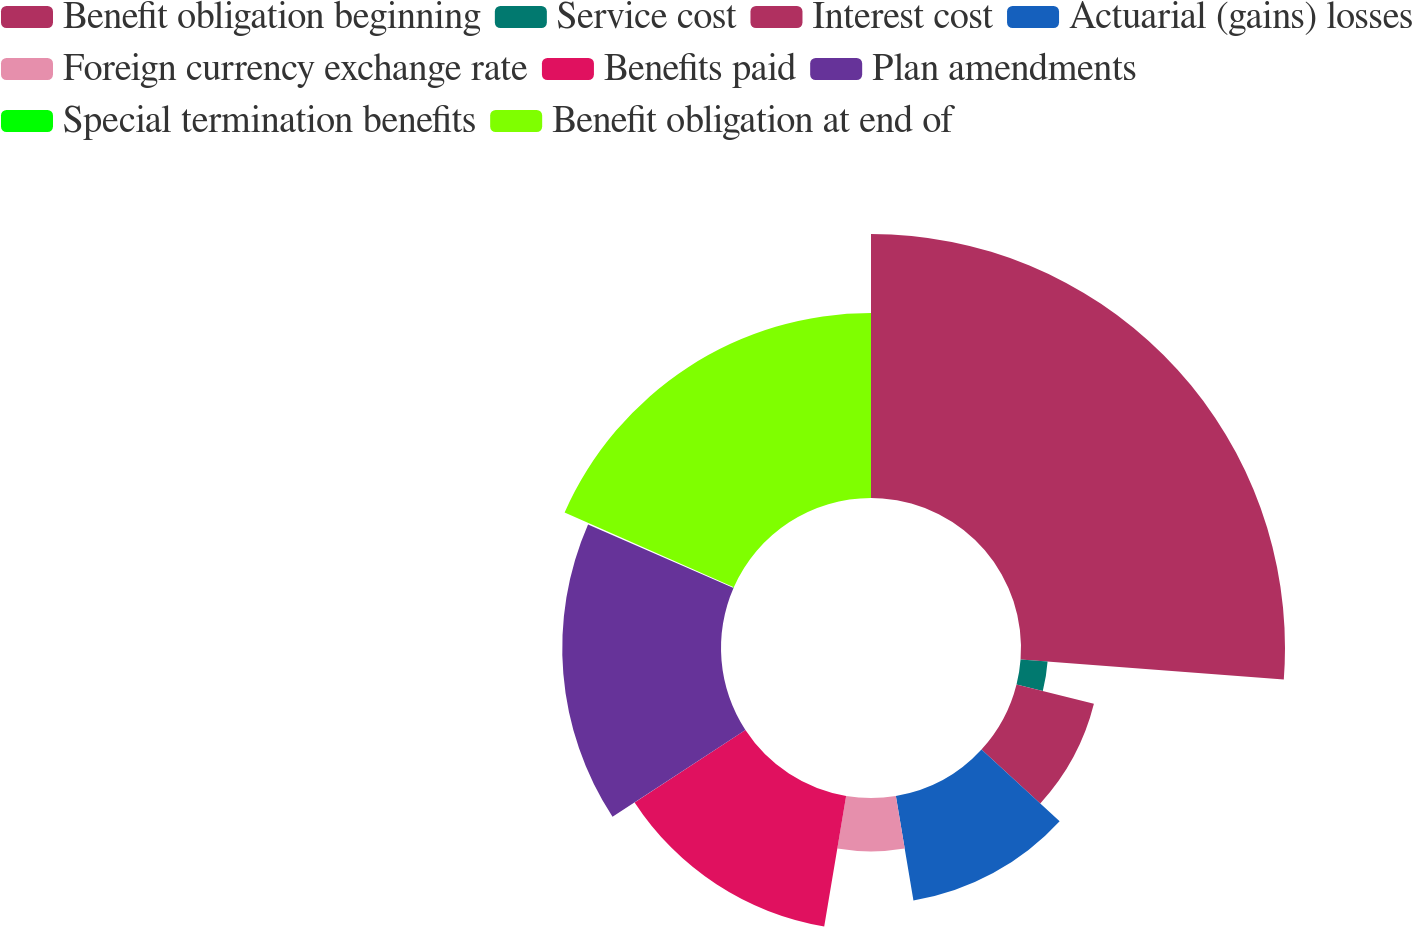<chart> <loc_0><loc_0><loc_500><loc_500><pie_chart><fcel>Benefit obligation beginning<fcel>Service cost<fcel>Interest cost<fcel>Actuarial (gains) losses<fcel>Foreign currency exchange rate<fcel>Benefits paid<fcel>Plan amendments<fcel>Special termination benefits<fcel>Benefit obligation at end of<nl><fcel>26.21%<fcel>2.69%<fcel>7.92%<fcel>10.53%<fcel>5.3%<fcel>13.14%<fcel>15.76%<fcel>0.08%<fcel>18.37%<nl></chart> 